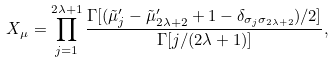Convert formula to latex. <formula><loc_0><loc_0><loc_500><loc_500>X _ { \mu } = \prod _ { j = 1 } ^ { 2 \lambda + 1 } \frac { \Gamma [ ( \tilde { \mu } _ { j } ^ { \prime } - \tilde { \mu } _ { 2 \lambda + 2 } ^ { \prime } + 1 - \delta _ { \sigma _ { j } \sigma _ { 2 \lambda + 2 } } ) / 2 ] } { \Gamma [ j / ( 2 \lambda + 1 ) ] } ,</formula> 